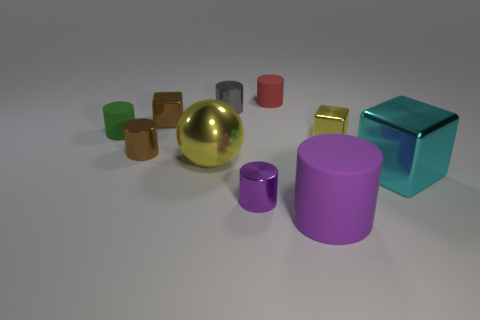Is the block that is on the left side of the red cylinder made of the same material as the purple thing right of the red cylinder?
Offer a very short reply. No. The small shiny object that is the same color as the metal sphere is what shape?
Keep it short and to the point. Cube. What number of objects are either large objects that are on the left side of the red rubber object or metal cylinders that are left of the brown block?
Give a very brief answer. 2. There is a metal cylinder on the left side of the yellow metal ball; does it have the same color as the tiny rubber thing to the left of the tiny brown cube?
Ensure brevity in your answer.  No. What is the shape of the metal object that is behind the brown cylinder and on the left side of the big yellow metal ball?
Provide a succinct answer. Cube. There is a sphere that is the same size as the cyan metallic cube; what is its color?
Make the answer very short. Yellow. Is there a tiny thing that has the same color as the big rubber cylinder?
Make the answer very short. Yes. Do the yellow metallic thing in front of the small yellow metallic block and the purple object to the right of the red matte thing have the same size?
Your answer should be very brief. Yes. There is a object that is right of the small red cylinder and behind the small brown metallic cylinder; what is its material?
Your response must be concise. Metal. What number of other objects are there of the same size as the purple rubber cylinder?
Offer a very short reply. 2. 